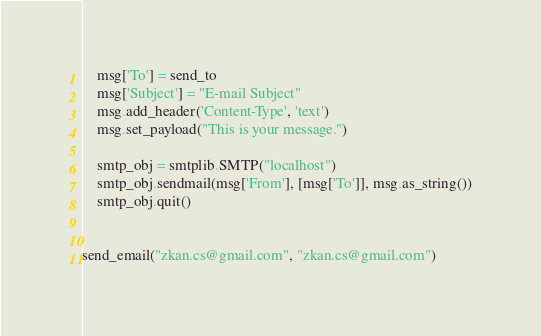<code> <loc_0><loc_0><loc_500><loc_500><_Python_>    msg['To'] = send_to
    msg['Subject'] = "E-mail Subject"
    msg.add_header('Content-Type', 'text')
    msg.set_payload("This is your message.")

    smtp_obj = smtplib.SMTP("localhost")
    smtp_obj.sendmail(msg['From'], [msg['To']], msg.as_string())
    smtp_obj.quit()


send_email("zkan.cs@gmail.com", "zkan.cs@gmail.com")
</code> 